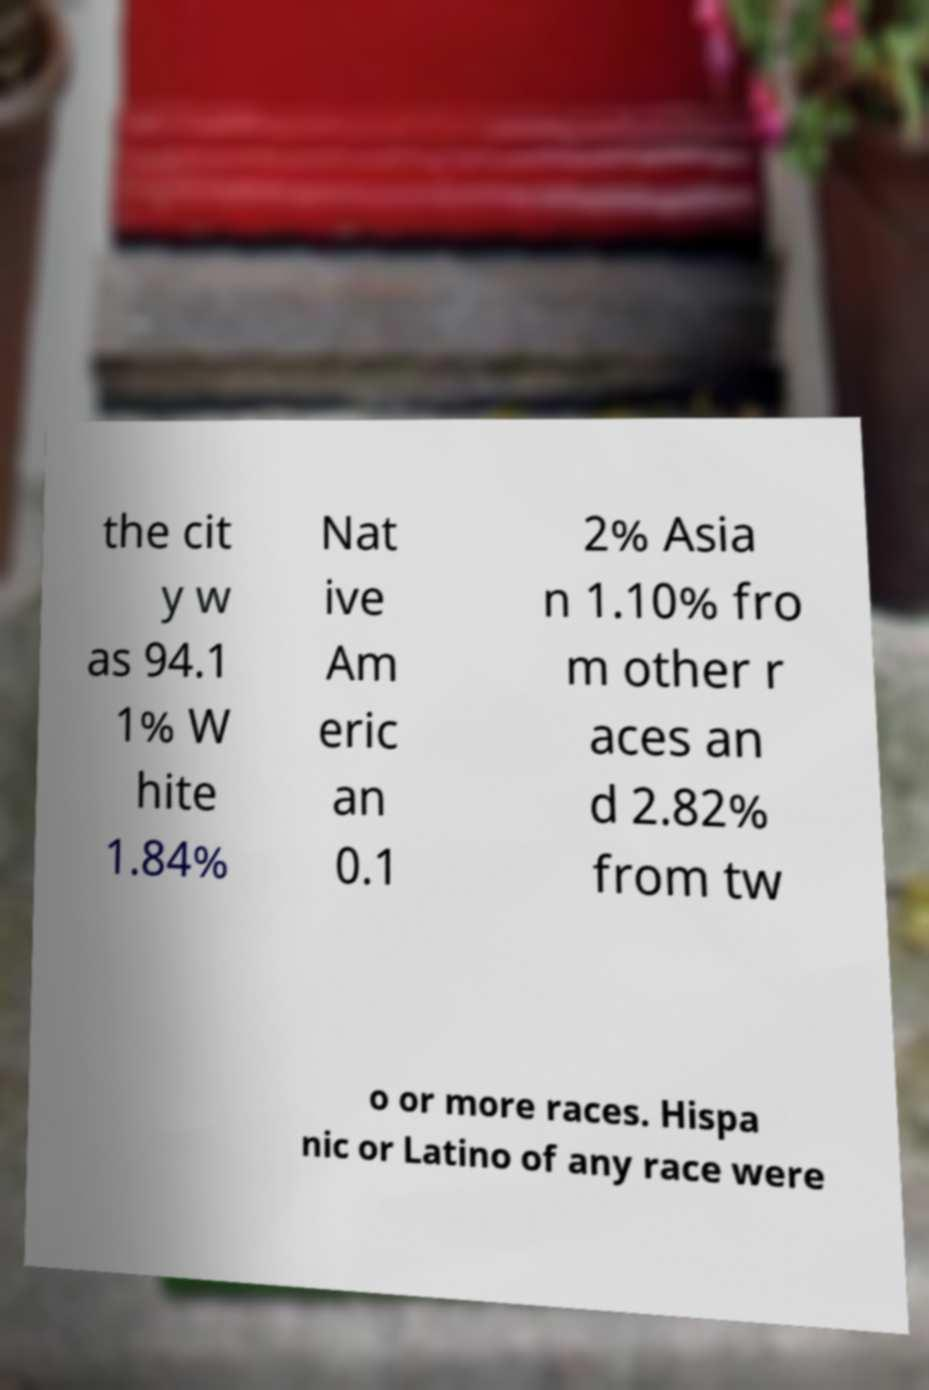Can you accurately transcribe the text from the provided image for me? the cit y w as 94.1 1% W hite 1.84% Nat ive Am eric an 0.1 2% Asia n 1.10% fro m other r aces an d 2.82% from tw o or more races. Hispa nic or Latino of any race were 